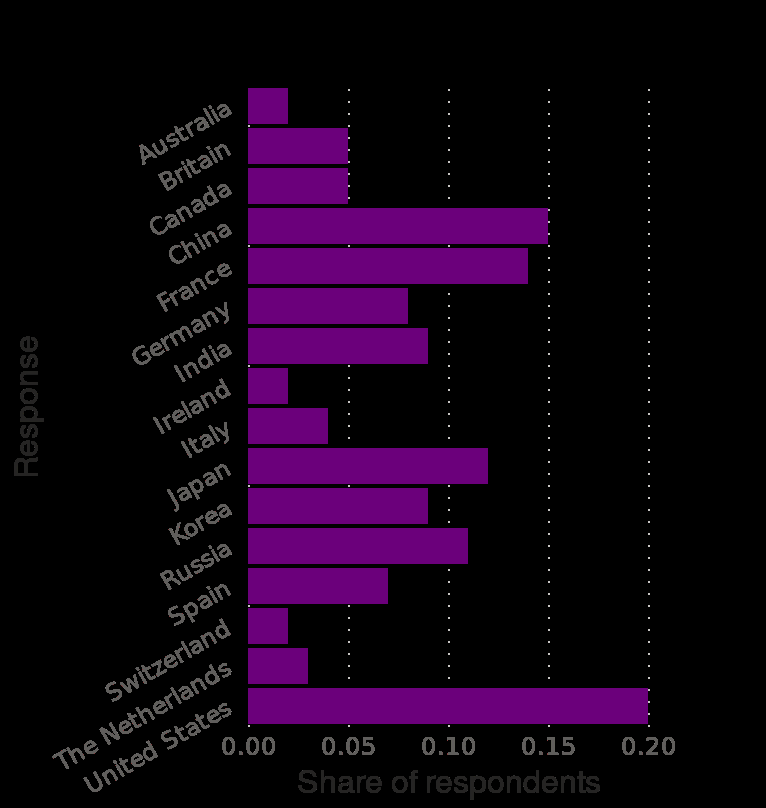<image>
How are Canadian tourists perceived?  Canadian tourists are perceived in the same way as British tourists. Which axis measures the response in the bar diagram? The y-axis measures the response in the bar diagram. 